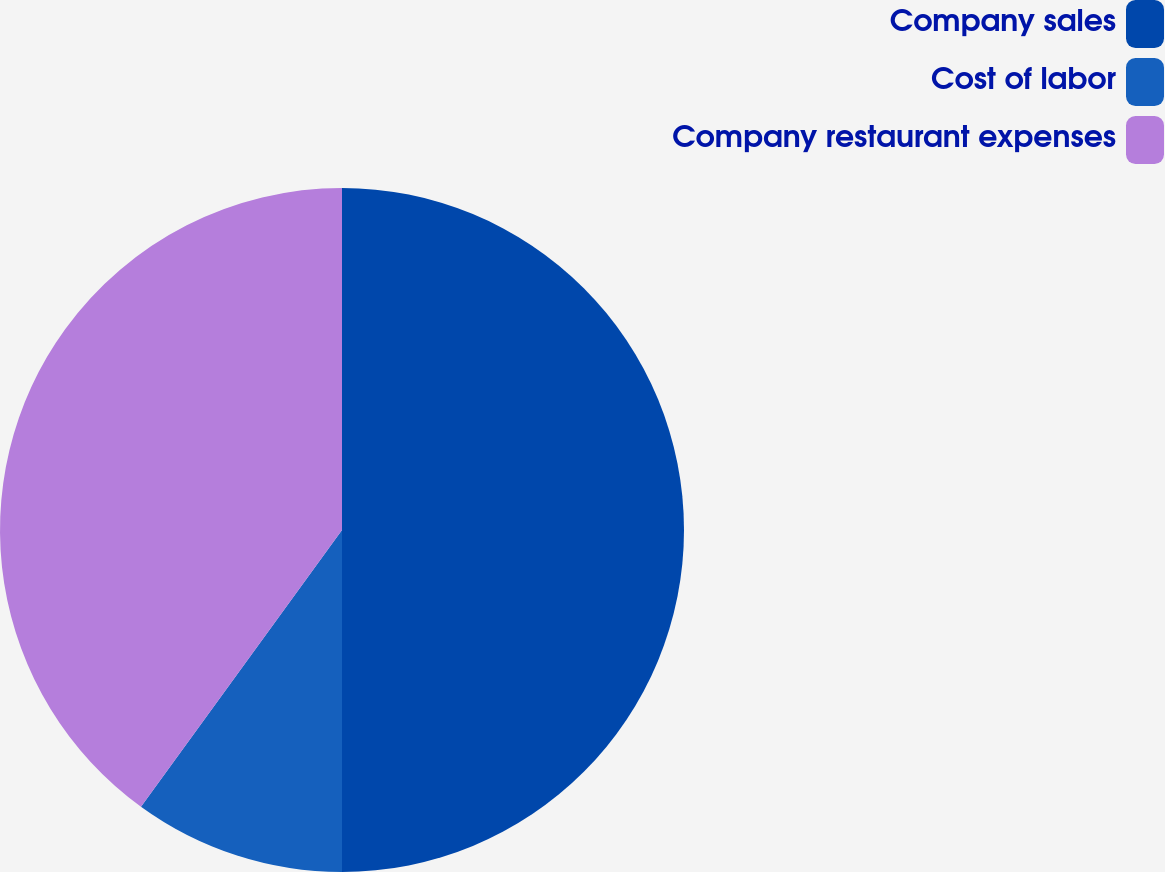<chart> <loc_0><loc_0><loc_500><loc_500><pie_chart><fcel>Company sales<fcel>Cost of labor<fcel>Company restaurant expenses<nl><fcel>50.0%<fcel>10.0%<fcel>40.0%<nl></chart> 